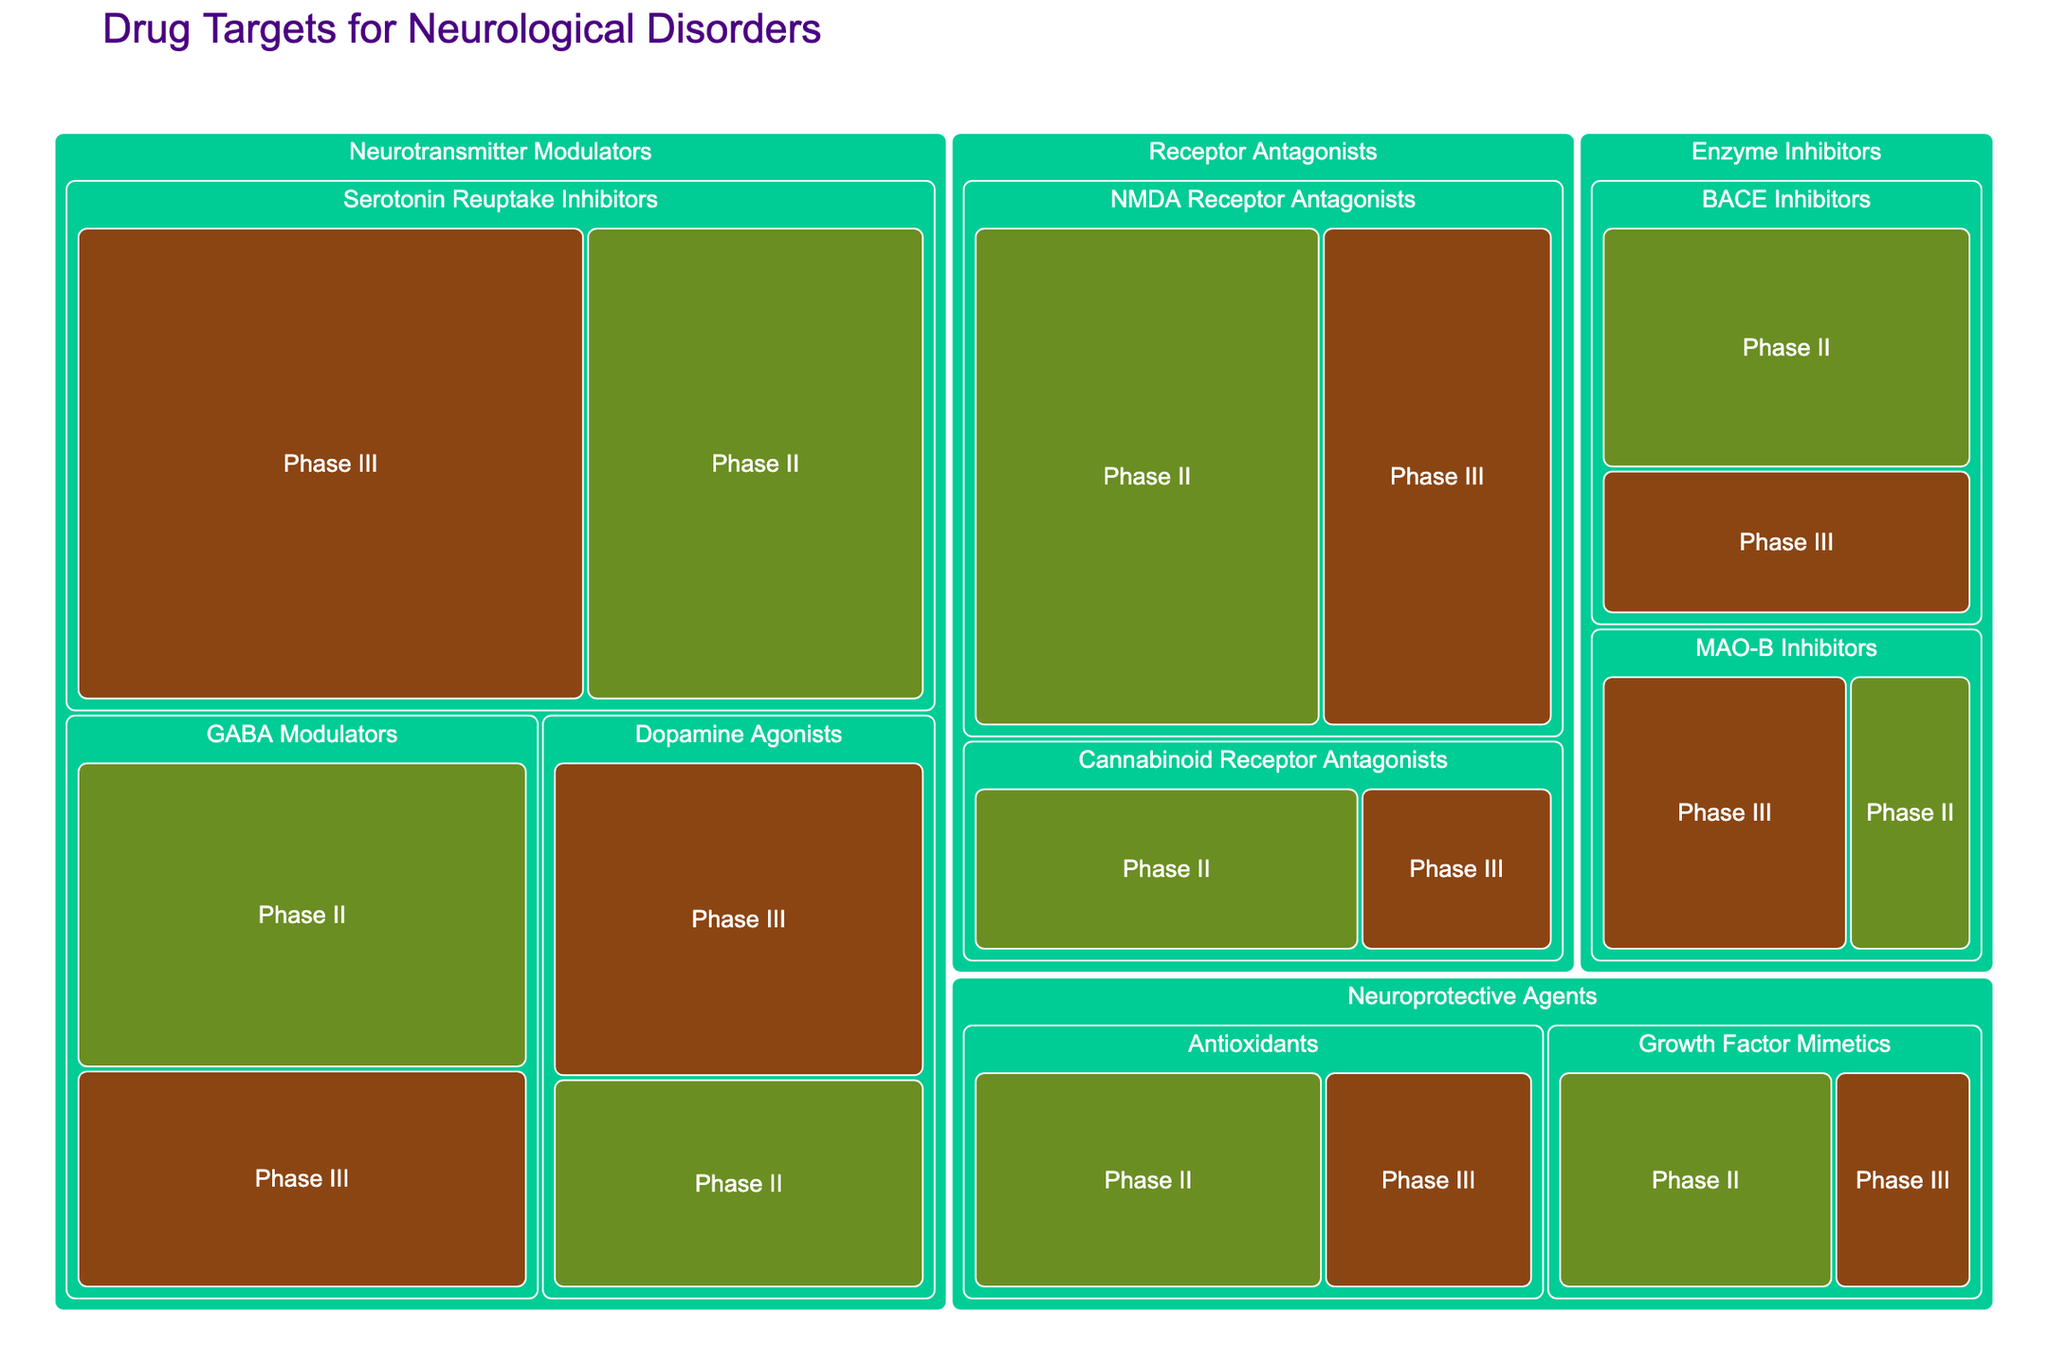What is the title of the figure? The title is usually present at the top of the figure and helps to understand the context or main topic the figure is representing. In this case, it is displayed clearly.
Answer: Drug Targets for Neurological Disorders Which development phase has more drug targets for Serotonin Reuptake Inhibitors? Look at the section of the Serotonin Reuptake Inhibitors in the Neurotransmitter Modulators class. Compare the count for Phase II and Phase III.
Answer: Phase III How many drug targets are there in total for Phase II GABA Modulators? Locate GABA Modulators under Neurotransmitter Modulators and look at the count for Phase II.
Answer: 7 What mechanism of action has the least number of drug targets in Phase III? Identify the counts for all mechanisms of action in Phase III and find the one with the smallest count.
Answer: Cannabinoid Receptor Antagonists What is the total number of drug targets for Neuroprotective Agents across all phases? Sum the numbers provided for Neuroprotective Agents in all phases.
Answer: 14 Which drug class has the highest number of targets in Phase III? Look at the numbers under Phase III for each drug class and find the one with the highest sum.
Answer: Neurotransmitter Modulators How does the number of Phase III Dopamine Agonists compare to Phase II Dopamine Agonists? Compare the counts for Dopamine Agonists in Phase III and Phase II.
Answer: Phase III has 2 more targets than Phase II What is the combined total of drug targets for both phases under Enzyme Inhibitors? Sum all the counts listed under Enzyme Inhibitors for both Phase II and Phase III.
Answer: 14 Is there a mechanism of action that is only in Phase III and not in Phase II? Verify if any mechanism of action is present under Phase III but not listed under Phase II.
Answer: No Which mechanism of action under Receptor Antagonists has more targets in Phase II than in Phase III? Compare the counts for each mechanism under Receptor Antagonists between the two phases.
Answer: NMDA Receptor Antagonists 